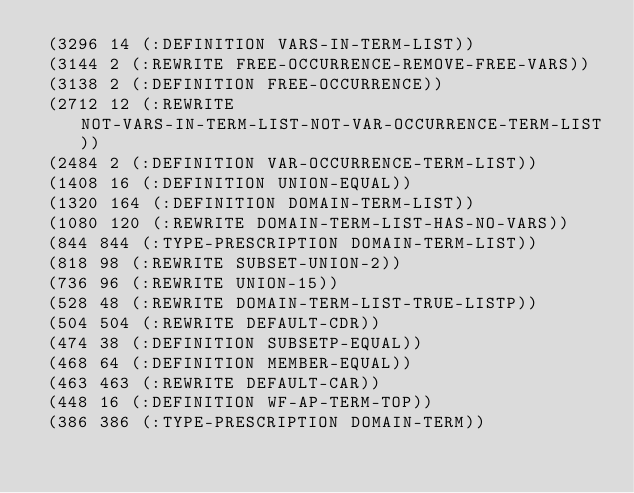<code> <loc_0><loc_0><loc_500><loc_500><_Lisp_> (3296 14 (:DEFINITION VARS-IN-TERM-LIST))
 (3144 2 (:REWRITE FREE-OCCURRENCE-REMOVE-FREE-VARS))
 (3138 2 (:DEFINITION FREE-OCCURRENCE))
 (2712 12 (:REWRITE NOT-VARS-IN-TERM-LIST-NOT-VAR-OCCURRENCE-TERM-LIST))
 (2484 2 (:DEFINITION VAR-OCCURRENCE-TERM-LIST))
 (1408 16 (:DEFINITION UNION-EQUAL))
 (1320 164 (:DEFINITION DOMAIN-TERM-LIST))
 (1080 120 (:REWRITE DOMAIN-TERM-LIST-HAS-NO-VARS))
 (844 844 (:TYPE-PRESCRIPTION DOMAIN-TERM-LIST))
 (818 98 (:REWRITE SUBSET-UNION-2))
 (736 96 (:REWRITE UNION-15))
 (528 48 (:REWRITE DOMAIN-TERM-LIST-TRUE-LISTP))
 (504 504 (:REWRITE DEFAULT-CDR))
 (474 38 (:DEFINITION SUBSETP-EQUAL))
 (468 64 (:DEFINITION MEMBER-EQUAL))
 (463 463 (:REWRITE DEFAULT-CAR))
 (448 16 (:DEFINITION WF-AP-TERM-TOP))
 (386 386 (:TYPE-PRESCRIPTION DOMAIN-TERM))</code> 